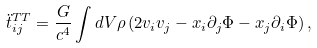<formula> <loc_0><loc_0><loc_500><loc_500>\ddot { t } _ { i j } ^ { T T } = \frac { G } { c ^ { 4 } } \int d V \rho \left ( 2 v _ { i } v _ { j } - x _ { i } \partial _ { j } \Phi - x _ { j } \partial _ { i } \Phi \right ) ,</formula> 